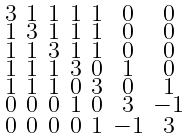<formula> <loc_0><loc_0><loc_500><loc_500>\begin{smallmatrix} 3 & 1 & 1 & 1 & 1 & 0 & 0 \\ 1 & 3 & 1 & 1 & 1 & 0 & 0 \\ 1 & 1 & 3 & 1 & 1 & 0 & 0 \\ 1 & 1 & 1 & 3 & 0 & 1 & 0 \\ 1 & 1 & 1 & 0 & 3 & 0 & 1 \\ 0 & 0 & 0 & 1 & 0 & 3 & - 1 \\ 0 & 0 & 0 & 0 & 1 & - 1 & 3 \end{smallmatrix}</formula> 